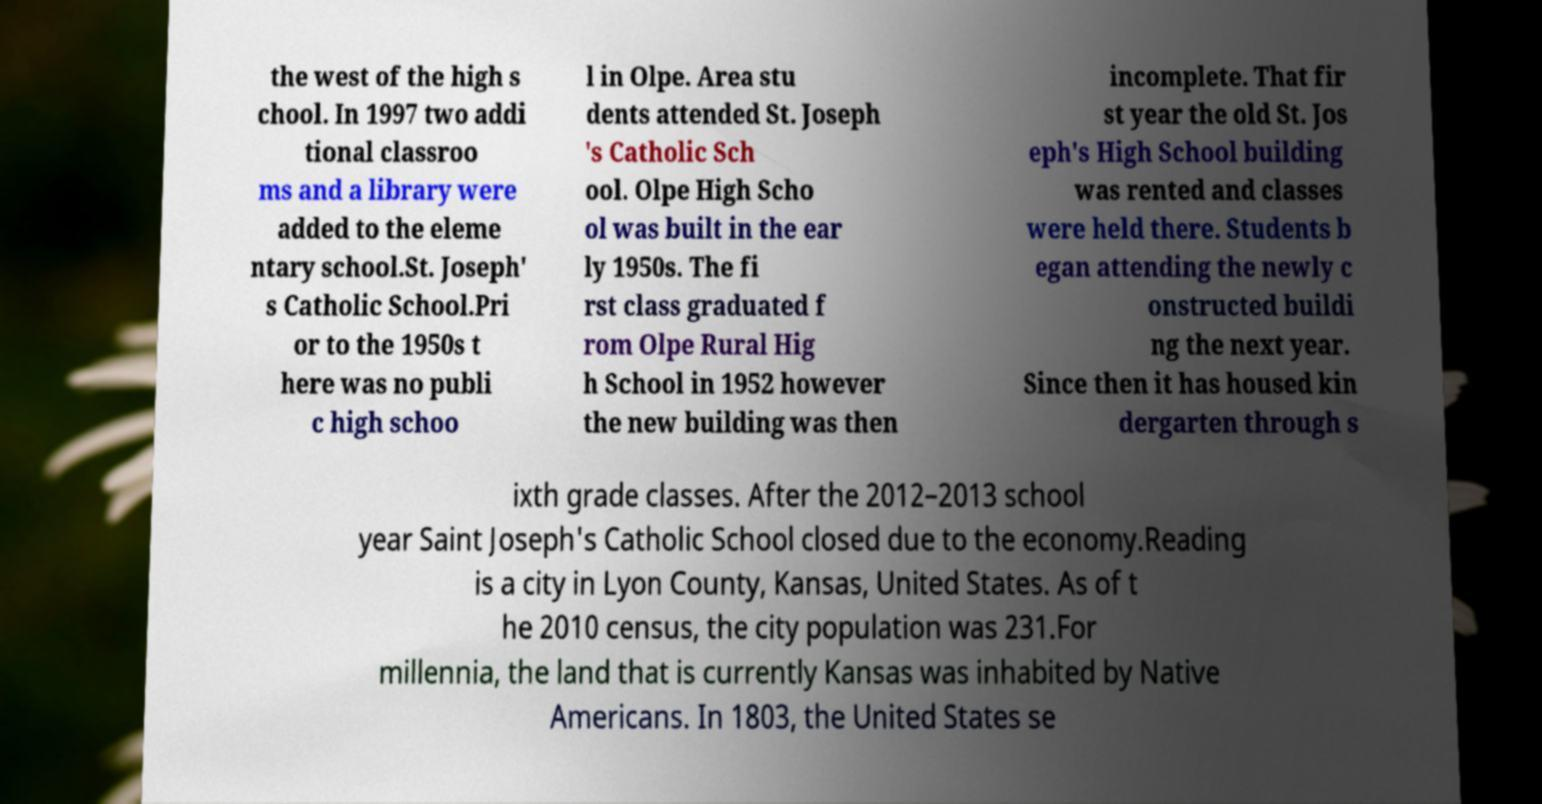There's text embedded in this image that I need extracted. Can you transcribe it verbatim? the west of the high s chool. In 1997 two addi tional classroo ms and a library were added to the eleme ntary school.St. Joseph' s Catholic School.Pri or to the 1950s t here was no publi c high schoo l in Olpe. Area stu dents attended St. Joseph 's Catholic Sch ool. Olpe High Scho ol was built in the ear ly 1950s. The fi rst class graduated f rom Olpe Rural Hig h School in 1952 however the new building was then incomplete. That fir st year the old St. Jos eph's High School building was rented and classes were held there. Students b egan attending the newly c onstructed buildi ng the next year. Since then it has housed kin dergarten through s ixth grade classes. After the 2012–2013 school year Saint Joseph's Catholic School closed due to the economy.Reading is a city in Lyon County, Kansas, United States. As of t he 2010 census, the city population was 231.For millennia, the land that is currently Kansas was inhabited by Native Americans. In 1803, the United States se 